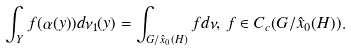Convert formula to latex. <formula><loc_0><loc_0><loc_500><loc_500>\int _ { Y } f ( \alpha ( y ) ) d \nu _ { 1 } ( y ) = \int _ { G / \hat { x } _ { 0 } ( H ) } f d \nu , \, f \in C _ { c } ( G / \hat { x } _ { 0 } ( H ) ) .</formula> 